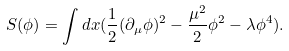<formula> <loc_0><loc_0><loc_500><loc_500>S ( \phi ) = \int d x ( \frac { 1 } { 2 } ( \partial _ { \mu } \phi ) ^ { 2 } - \frac { \mu ^ { 2 } } { 2 } \phi ^ { 2 } - \lambda \phi ^ { 4 } ) .</formula> 